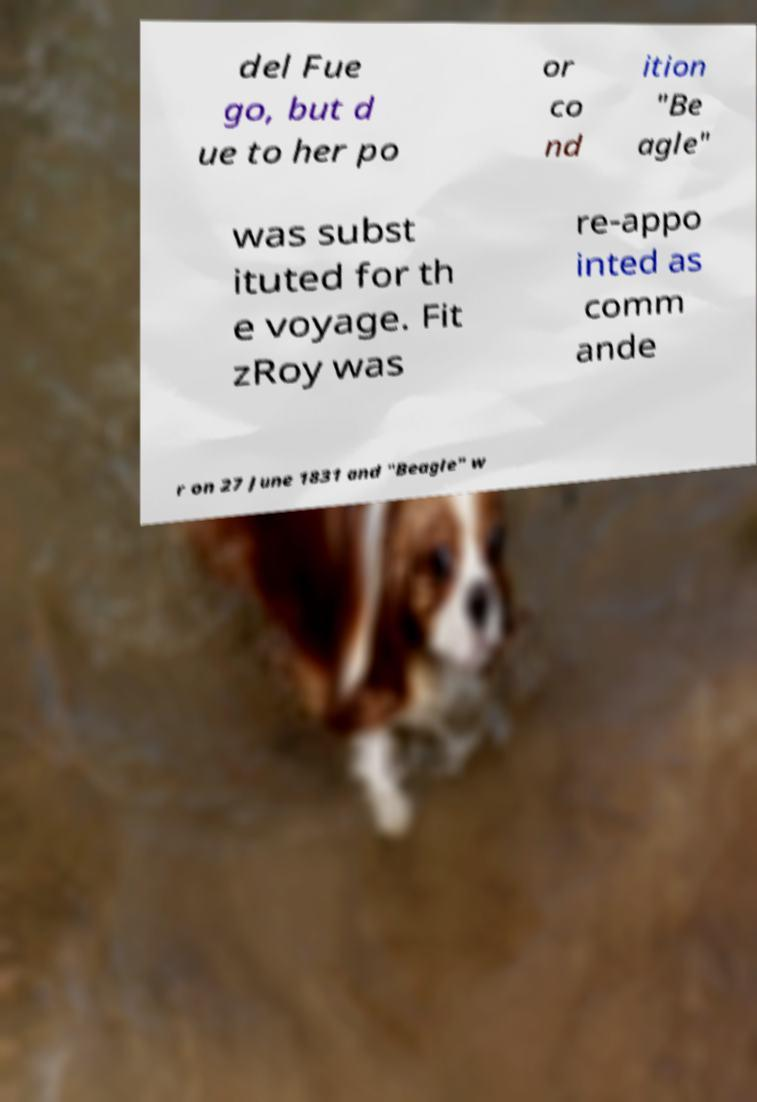Can you read and provide the text displayed in the image?This photo seems to have some interesting text. Can you extract and type it out for me? del Fue go, but d ue to her po or co nd ition "Be agle" was subst ituted for th e voyage. Fit zRoy was re-appo inted as comm ande r on 27 June 1831 and "Beagle" w 